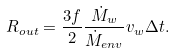Convert formula to latex. <formula><loc_0><loc_0><loc_500><loc_500>R _ { o u t } = \frac { 3 f } { 2 } \frac { \dot { M } _ { w } } { \dot { M } _ { e n v } } v _ { w } \Delta t .</formula> 